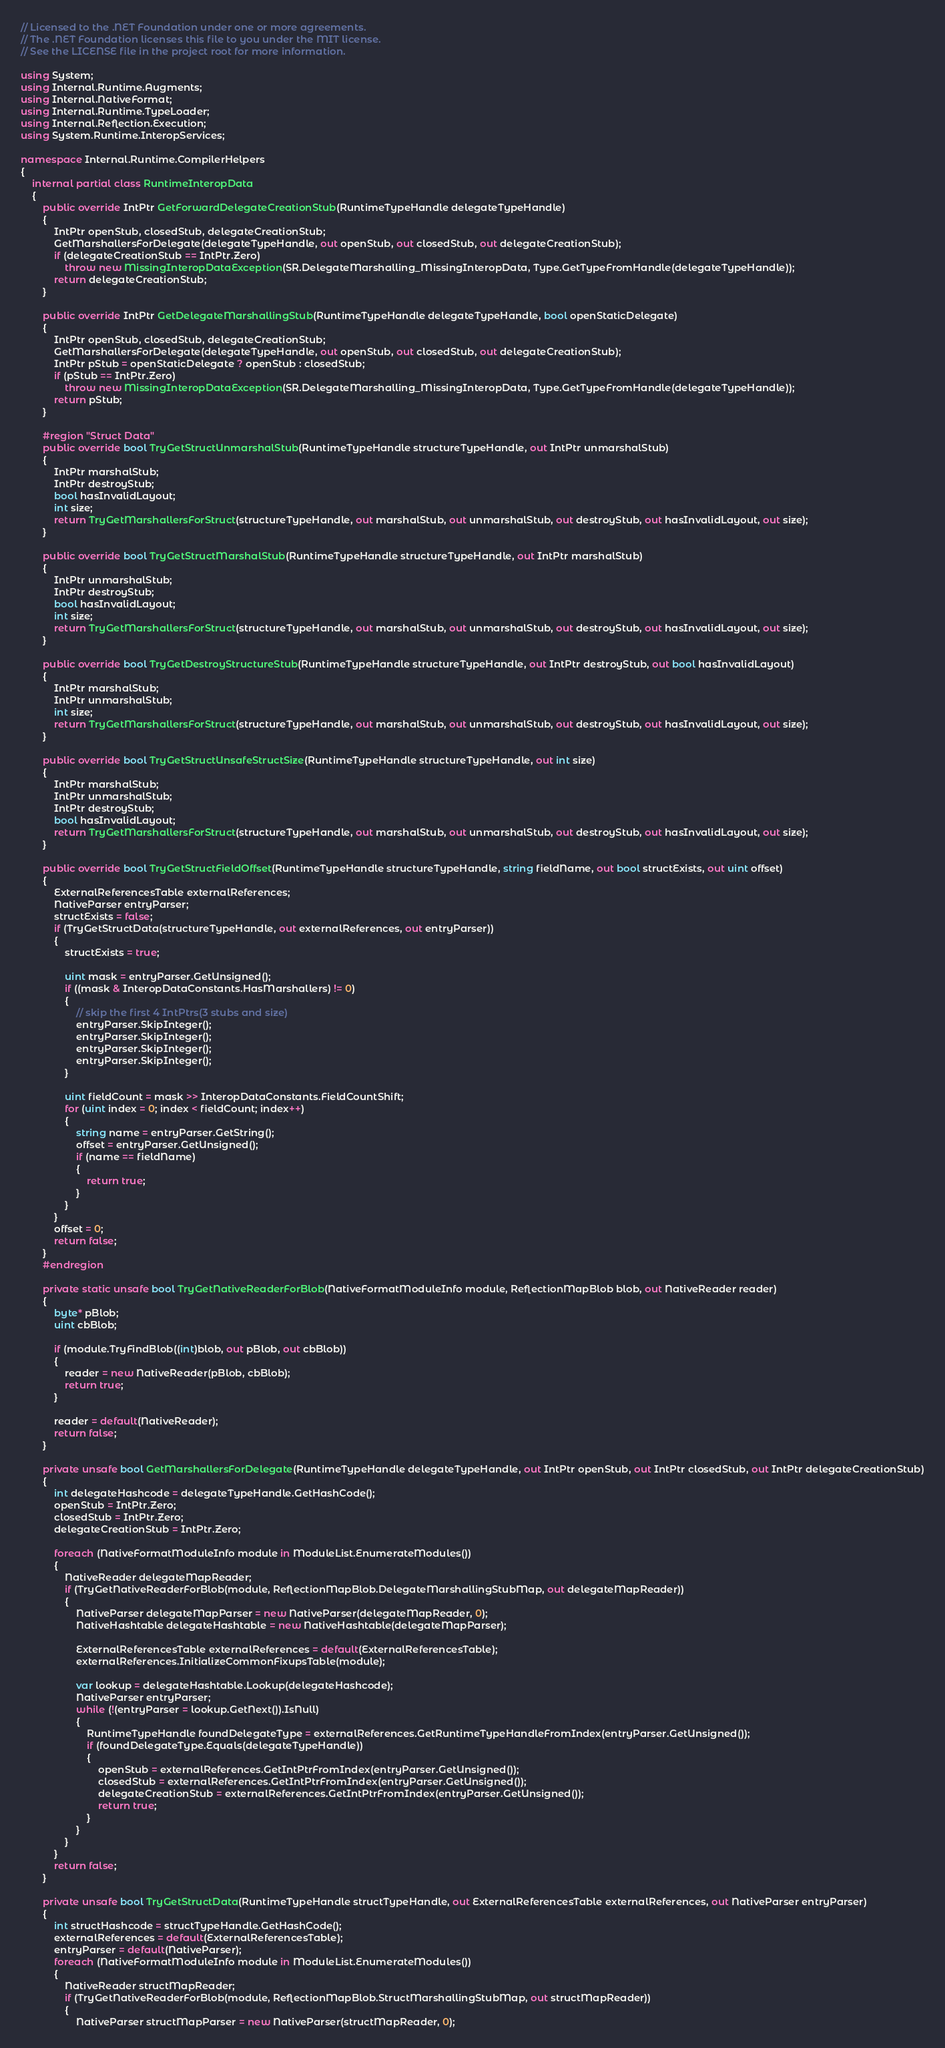<code> <loc_0><loc_0><loc_500><loc_500><_C#_>// Licensed to the .NET Foundation under one or more agreements.
// The .NET Foundation licenses this file to you under the MIT license.
// See the LICENSE file in the project root for more information.

using System;
using Internal.Runtime.Augments;
using Internal.NativeFormat;
using Internal.Runtime.TypeLoader;
using Internal.Reflection.Execution;
using System.Runtime.InteropServices;

namespace Internal.Runtime.CompilerHelpers
{
    internal partial class RuntimeInteropData
    {
        public override IntPtr GetForwardDelegateCreationStub(RuntimeTypeHandle delegateTypeHandle)
        {
            IntPtr openStub, closedStub, delegateCreationStub;
            GetMarshallersForDelegate(delegateTypeHandle, out openStub, out closedStub, out delegateCreationStub);
            if (delegateCreationStub == IntPtr.Zero)
                throw new MissingInteropDataException(SR.DelegateMarshalling_MissingInteropData, Type.GetTypeFromHandle(delegateTypeHandle));
            return delegateCreationStub;
        }

        public override IntPtr GetDelegateMarshallingStub(RuntimeTypeHandle delegateTypeHandle, bool openStaticDelegate)
        {
            IntPtr openStub, closedStub, delegateCreationStub;
            GetMarshallersForDelegate(delegateTypeHandle, out openStub, out closedStub, out delegateCreationStub);
            IntPtr pStub = openStaticDelegate ? openStub : closedStub;
            if (pStub == IntPtr.Zero)
                throw new MissingInteropDataException(SR.DelegateMarshalling_MissingInteropData, Type.GetTypeFromHandle(delegateTypeHandle));
            return pStub;
        }

        #region "Struct Data"
        public override bool TryGetStructUnmarshalStub(RuntimeTypeHandle structureTypeHandle, out IntPtr unmarshalStub)
        {
            IntPtr marshalStub;
            IntPtr destroyStub;
            bool hasInvalidLayout;
            int size;
            return TryGetMarshallersForStruct(structureTypeHandle, out marshalStub, out unmarshalStub, out destroyStub, out hasInvalidLayout, out size);
        }

        public override bool TryGetStructMarshalStub(RuntimeTypeHandle structureTypeHandle, out IntPtr marshalStub)
        {
            IntPtr unmarshalStub;
            IntPtr destroyStub;
            bool hasInvalidLayout;
            int size;
            return TryGetMarshallersForStruct(structureTypeHandle, out marshalStub, out unmarshalStub, out destroyStub, out hasInvalidLayout, out size);
        }

        public override bool TryGetDestroyStructureStub(RuntimeTypeHandle structureTypeHandle, out IntPtr destroyStub, out bool hasInvalidLayout)
        {
            IntPtr marshalStub;
            IntPtr unmarshalStub;
            int size;
            return TryGetMarshallersForStruct(structureTypeHandle, out marshalStub, out unmarshalStub, out destroyStub, out hasInvalidLayout, out size);
        }

        public override bool TryGetStructUnsafeStructSize(RuntimeTypeHandle structureTypeHandle, out int size)
        {
            IntPtr marshalStub;
            IntPtr unmarshalStub;
            IntPtr destroyStub;
            bool hasInvalidLayout;
            return TryGetMarshallersForStruct(structureTypeHandle, out marshalStub, out unmarshalStub, out destroyStub, out hasInvalidLayout, out size);
        }

        public override bool TryGetStructFieldOffset(RuntimeTypeHandle structureTypeHandle, string fieldName, out bool structExists, out uint offset)
        {
            ExternalReferencesTable externalReferences;
            NativeParser entryParser;
            structExists = false;
            if (TryGetStructData(structureTypeHandle, out externalReferences, out entryParser))
            {
                structExists = true;

                uint mask = entryParser.GetUnsigned();
                if ((mask & InteropDataConstants.HasMarshallers) != 0)
                {
                    // skip the first 4 IntPtrs(3 stubs and size)
                    entryParser.SkipInteger();
                    entryParser.SkipInteger();
                    entryParser.SkipInteger();
                    entryParser.SkipInteger();
                }

                uint fieldCount = mask >> InteropDataConstants.FieldCountShift;
                for (uint index = 0; index < fieldCount; index++)
                {
                    string name = entryParser.GetString();
                    offset = entryParser.GetUnsigned();
                    if (name == fieldName)
                    {
                        return true;
                    }
                }
            }
            offset = 0;
            return false;
        }
        #endregion

        private static unsafe bool TryGetNativeReaderForBlob(NativeFormatModuleInfo module, ReflectionMapBlob blob, out NativeReader reader)
        {
            byte* pBlob;
            uint cbBlob;

            if (module.TryFindBlob((int)blob, out pBlob, out cbBlob))
            {
                reader = new NativeReader(pBlob, cbBlob);
                return true;
            }

            reader = default(NativeReader);
            return false;
        }

        private unsafe bool GetMarshallersForDelegate(RuntimeTypeHandle delegateTypeHandle, out IntPtr openStub, out IntPtr closedStub, out IntPtr delegateCreationStub)
        {
            int delegateHashcode = delegateTypeHandle.GetHashCode();
            openStub = IntPtr.Zero;
            closedStub = IntPtr.Zero;
            delegateCreationStub = IntPtr.Zero;

            foreach (NativeFormatModuleInfo module in ModuleList.EnumerateModules())
            {
                NativeReader delegateMapReader;
                if (TryGetNativeReaderForBlob(module, ReflectionMapBlob.DelegateMarshallingStubMap, out delegateMapReader))
                {
                    NativeParser delegateMapParser = new NativeParser(delegateMapReader, 0);
                    NativeHashtable delegateHashtable = new NativeHashtable(delegateMapParser);

                    ExternalReferencesTable externalReferences = default(ExternalReferencesTable);
                    externalReferences.InitializeCommonFixupsTable(module);

                    var lookup = delegateHashtable.Lookup(delegateHashcode);
                    NativeParser entryParser;
                    while (!(entryParser = lookup.GetNext()).IsNull)
                    {
                        RuntimeTypeHandle foundDelegateType = externalReferences.GetRuntimeTypeHandleFromIndex(entryParser.GetUnsigned());
                        if (foundDelegateType.Equals(delegateTypeHandle))
                        {
                            openStub = externalReferences.GetIntPtrFromIndex(entryParser.GetUnsigned());
                            closedStub = externalReferences.GetIntPtrFromIndex(entryParser.GetUnsigned());
                            delegateCreationStub = externalReferences.GetIntPtrFromIndex(entryParser.GetUnsigned());
                            return true;
                        }
                    }
                }
            }
            return false;
        }

        private unsafe bool TryGetStructData(RuntimeTypeHandle structTypeHandle, out ExternalReferencesTable externalReferences, out NativeParser entryParser)
        {
            int structHashcode = structTypeHandle.GetHashCode();
            externalReferences = default(ExternalReferencesTable);
            entryParser = default(NativeParser);
            foreach (NativeFormatModuleInfo module in ModuleList.EnumerateModules())
            {
                NativeReader structMapReader;
                if (TryGetNativeReaderForBlob(module, ReflectionMapBlob.StructMarshallingStubMap, out structMapReader))
                {
                    NativeParser structMapParser = new NativeParser(structMapReader, 0);</code> 